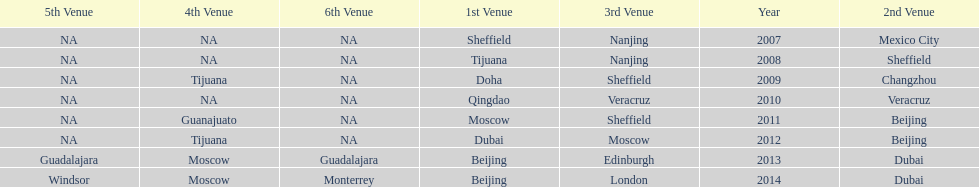Which year had more venues, 2007 or 2012? 2012. 